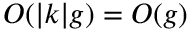Convert formula to latex. <formula><loc_0><loc_0><loc_500><loc_500>O ( | k | g ) = O ( g )</formula> 